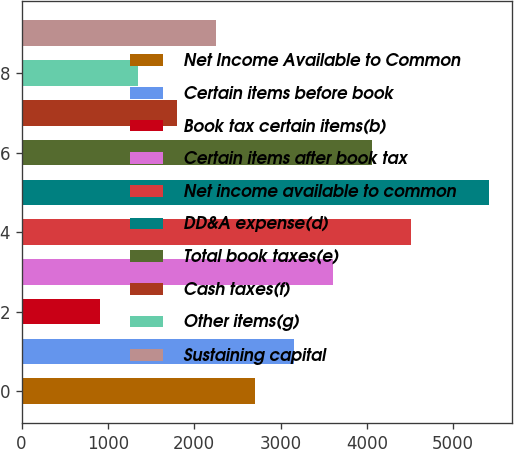<chart> <loc_0><loc_0><loc_500><loc_500><bar_chart><fcel>Net Income Available to Common<fcel>Certain items before book<fcel>Book tax certain items(b)<fcel>Certain items after book tax<fcel>Net income available to common<fcel>DD&A expense(d)<fcel>Total book taxes(e)<fcel>Cash taxes(f)<fcel>Other items(g)<fcel>Sustaining capital<nl><fcel>2706.8<fcel>3157.85<fcel>902.6<fcel>3608.9<fcel>4511<fcel>5413.1<fcel>4059.95<fcel>1804.7<fcel>1353.65<fcel>2255.75<nl></chart> 